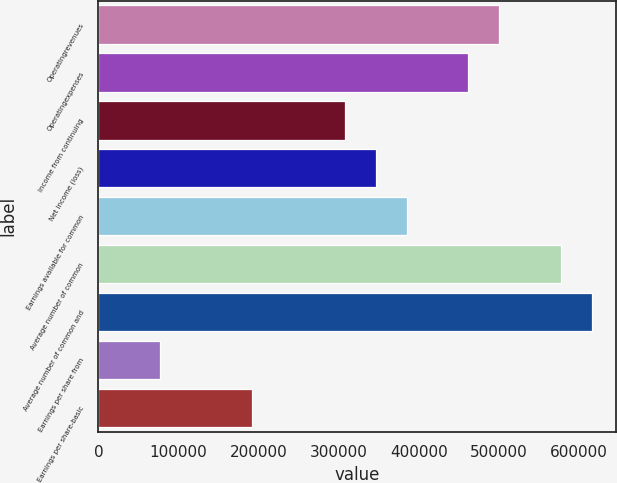Convert chart to OTSL. <chart><loc_0><loc_0><loc_500><loc_500><bar_chart><fcel>Operatingrevenues<fcel>Operatingexpenses<fcel>Income from continuing<fcel>Net income (loss)<fcel>Earnings available for common<fcel>Average number of common<fcel>Average number of common and<fcel>Earnings per share from<fcel>Earnings per share-basic<nl><fcel>500040<fcel>461575<fcel>307717<fcel>346182<fcel>384646<fcel>576968<fcel>615433<fcel>76930.1<fcel>192324<nl></chart> 